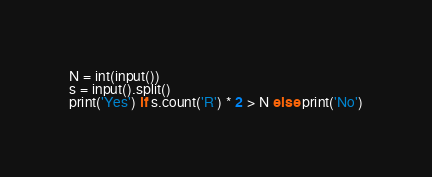Convert code to text. <code><loc_0><loc_0><loc_500><loc_500><_Python_>N = int(input())
s = input().split()
print('Yes') if s.count('R') * 2 > N else print('No')</code> 